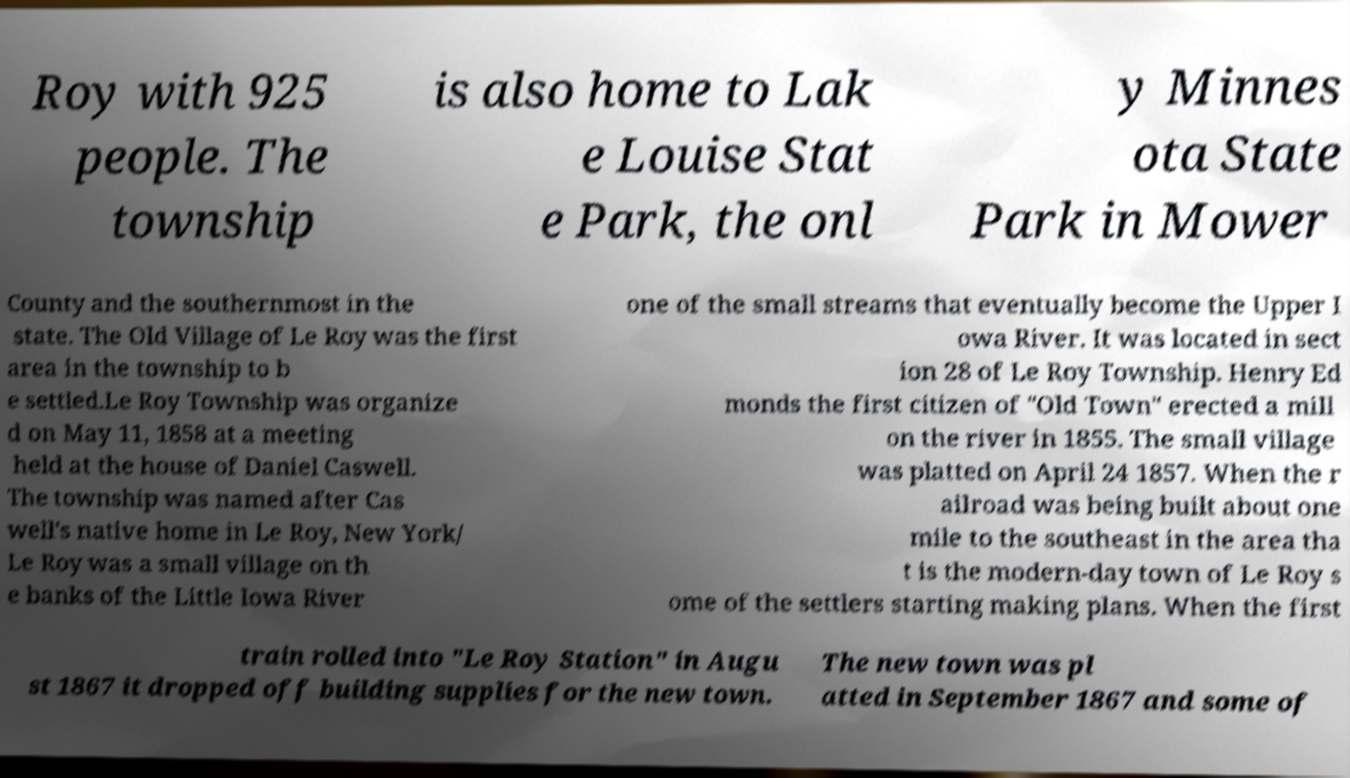Could you extract and type out the text from this image? Roy with 925 people. The township is also home to Lak e Louise Stat e Park, the onl y Minnes ota State Park in Mower County and the southernmost in the state. The Old Village of Le Roy was the first area in the township to b e settled.Le Roy Township was organize d on May 11, 1858 at a meeting held at the house of Daniel Caswell. The township was named after Cas well's native home in Le Roy, New York/ Le Roy was a small village on th e banks of the Little Iowa River one of the small streams that eventually become the Upper I owa River. It was located in sect ion 28 of Le Roy Township. Henry Ed monds the first citizen of "Old Town" erected a mill on the river in 1855. The small village was platted on April 24 1857. When the r ailroad was being built about one mile to the southeast in the area tha t is the modern-day town of Le Roy s ome of the settlers starting making plans. When the first train rolled into "Le Roy Station" in Augu st 1867 it dropped off building supplies for the new town. The new town was pl atted in September 1867 and some of 